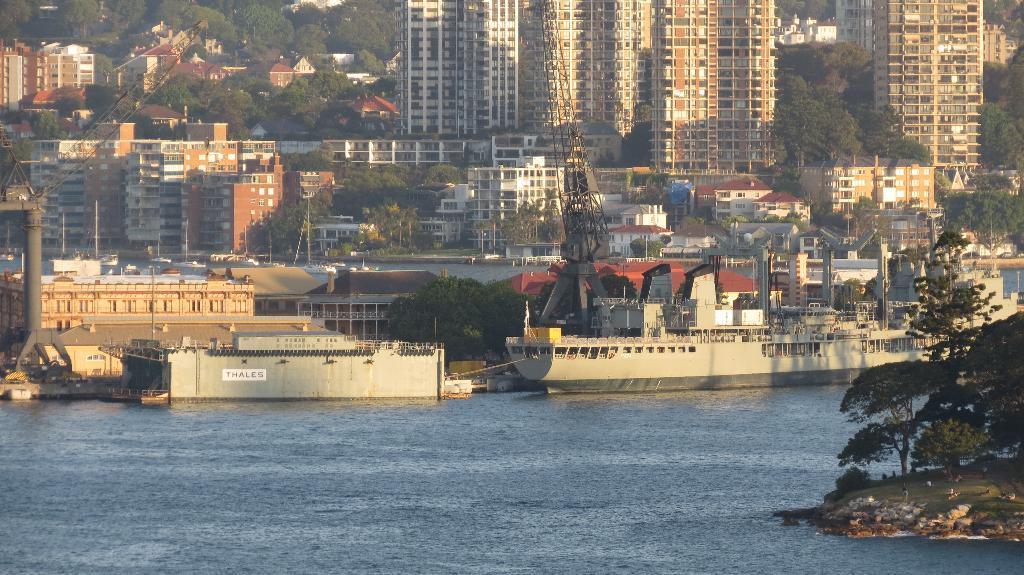Please provide a concise description of this image. In the image at the bottom we can see water and on the right side there are animals and trees on the ground. There is a big ship on the water and we can see container box, cranes, buildings and trees. In the background there are boats on the water, buildings, trees and houses. 